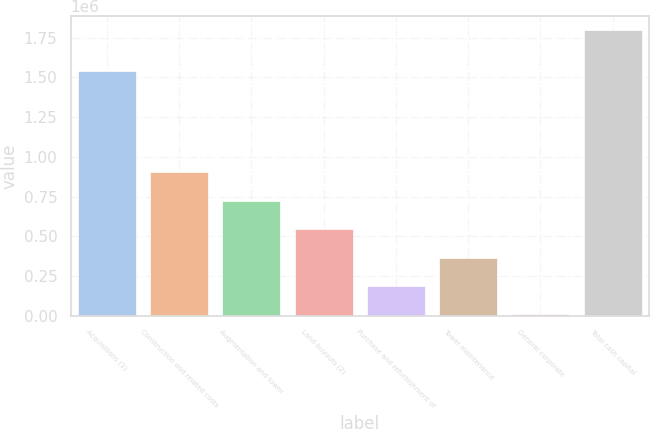Convert chart to OTSL. <chart><loc_0><loc_0><loc_500><loc_500><bar_chart><fcel>Acquisitions (1)<fcel>Construction and related costs<fcel>Augmentation and tower<fcel>Land buyouts (2)<fcel>Purchase and refurbishment of<fcel>Tower maintenance<fcel>General corporate<fcel>Total cash capital<nl><fcel>1.54026e+06<fcel>901835<fcel>722907<fcel>543980<fcel>186125<fcel>365052<fcel>7197<fcel>1.79647e+06<nl></chart> 